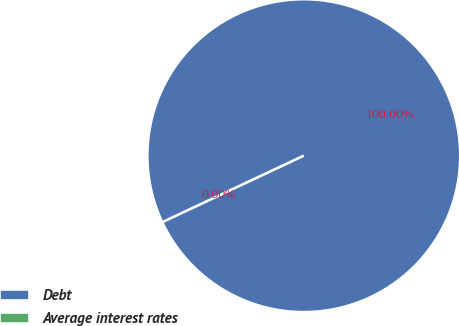<chart> <loc_0><loc_0><loc_500><loc_500><pie_chart><fcel>Debt<fcel>Average interest rates<nl><fcel>100.0%<fcel>0.0%<nl></chart> 